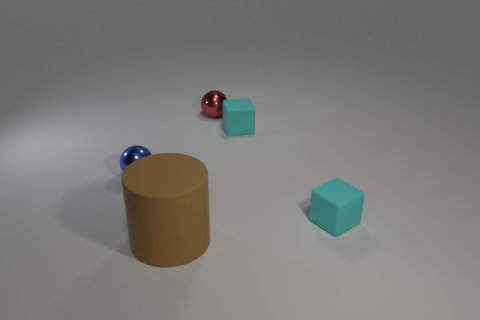How many big brown rubber things have the same shape as the blue thing?
Make the answer very short. 0. There is a tiny ball right of the brown cylinder; how many shiny spheres are left of it?
Provide a succinct answer. 1. How many matte things are small cubes or tiny things?
Provide a short and direct response. 2. Are there any big purple balls that have the same material as the blue sphere?
Offer a terse response. No. What number of objects are either metal things in front of the tiny red metal sphere or metal things in front of the red metallic object?
Your answer should be compact. 1. Do the thing to the left of the rubber cylinder and the big rubber object have the same color?
Give a very brief answer. No. How many other things are there of the same color as the cylinder?
Ensure brevity in your answer.  0. What is the blue thing made of?
Provide a succinct answer. Metal. Is the size of the metallic sphere on the left side of the red sphere the same as the red metallic ball?
Give a very brief answer. Yes. Is there any other thing that has the same size as the blue thing?
Your answer should be compact. Yes. 